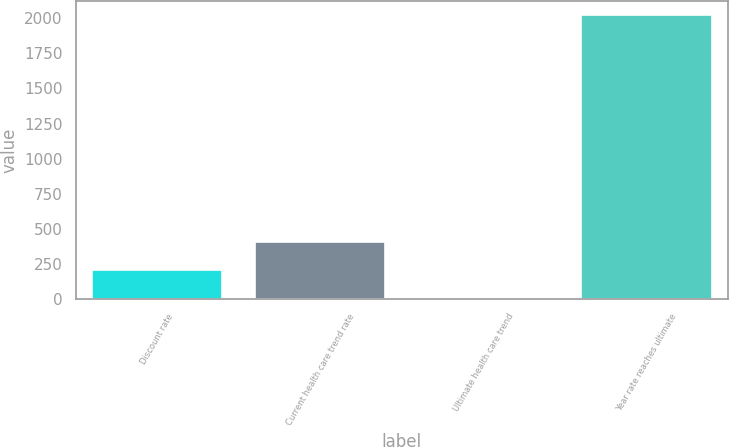<chart> <loc_0><loc_0><loc_500><loc_500><bar_chart><fcel>Discount rate<fcel>Current health care trend rate<fcel>Ultimate health care trend<fcel>Year rate reaches ultimate<nl><fcel>206.8<fcel>408.6<fcel>5<fcel>2023<nl></chart> 